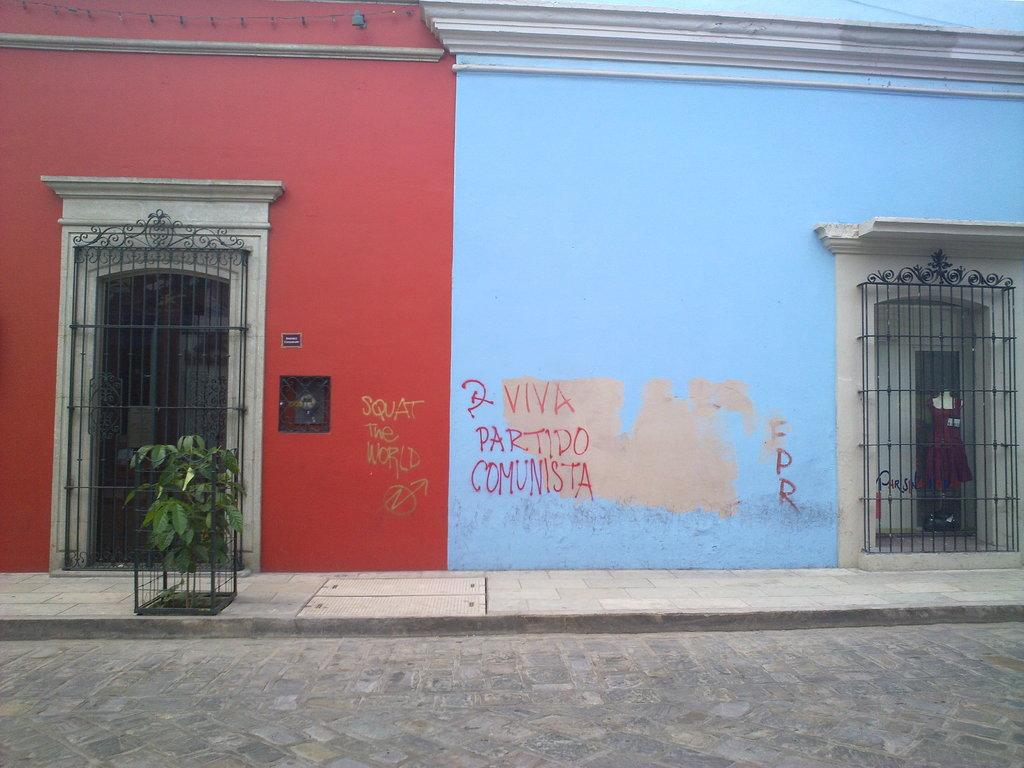What type of structures can be seen in the picture? There are buildings in the picture. What colors are the buildings? The buildings are red and blue in color. What type of vegetation is present in the picture? There is a plant in the picture. What architectural features can be seen on the buildings? There are doors in the picture. What can be found written on a wall in the picture? There is something written on a wall in the picture. What other objects can be seen in the picture besides the buildings and plant? There are other objects in the picture. Can you tell me how many crows are sitting on the roof of the red building in the picture? There are no crows present in the picture; it only features buildings, a plant, doors, something written on a wall, and other unspecified objects. 